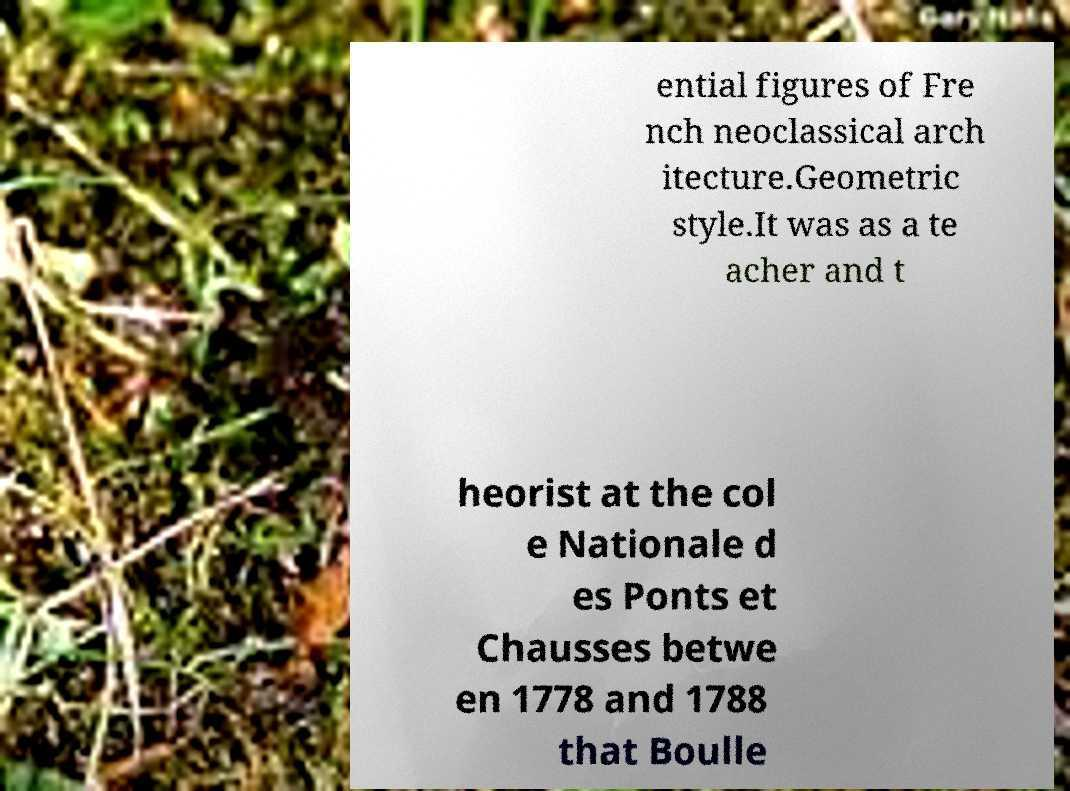I need the written content from this picture converted into text. Can you do that? ential figures of Fre nch neoclassical arch itecture.Geometric style.It was as a te acher and t heorist at the col e Nationale d es Ponts et Chausses betwe en 1778 and 1788 that Boulle 